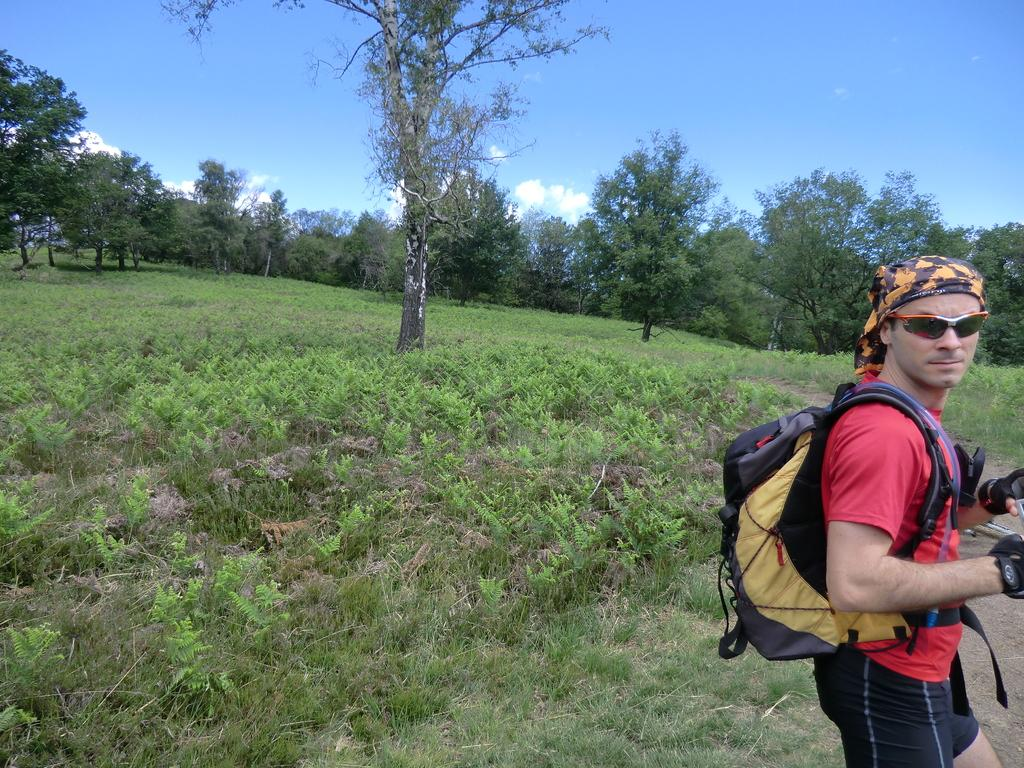What can be seen in the background of the image? There is a sky in the image. What type of natural elements are present in the image? There are trees and plants in the image. Can you describe the man's appearance in the image? There is a man wearing a bag on the right side of the image. What type of throne is the man sitting on in the image? There is no throne present in the image; the man is standing while wearing a bag. How does the man's feeling of happiness manifest in the image? The image does not provide information about the man's feelings, so it cannot be determined from the image. 